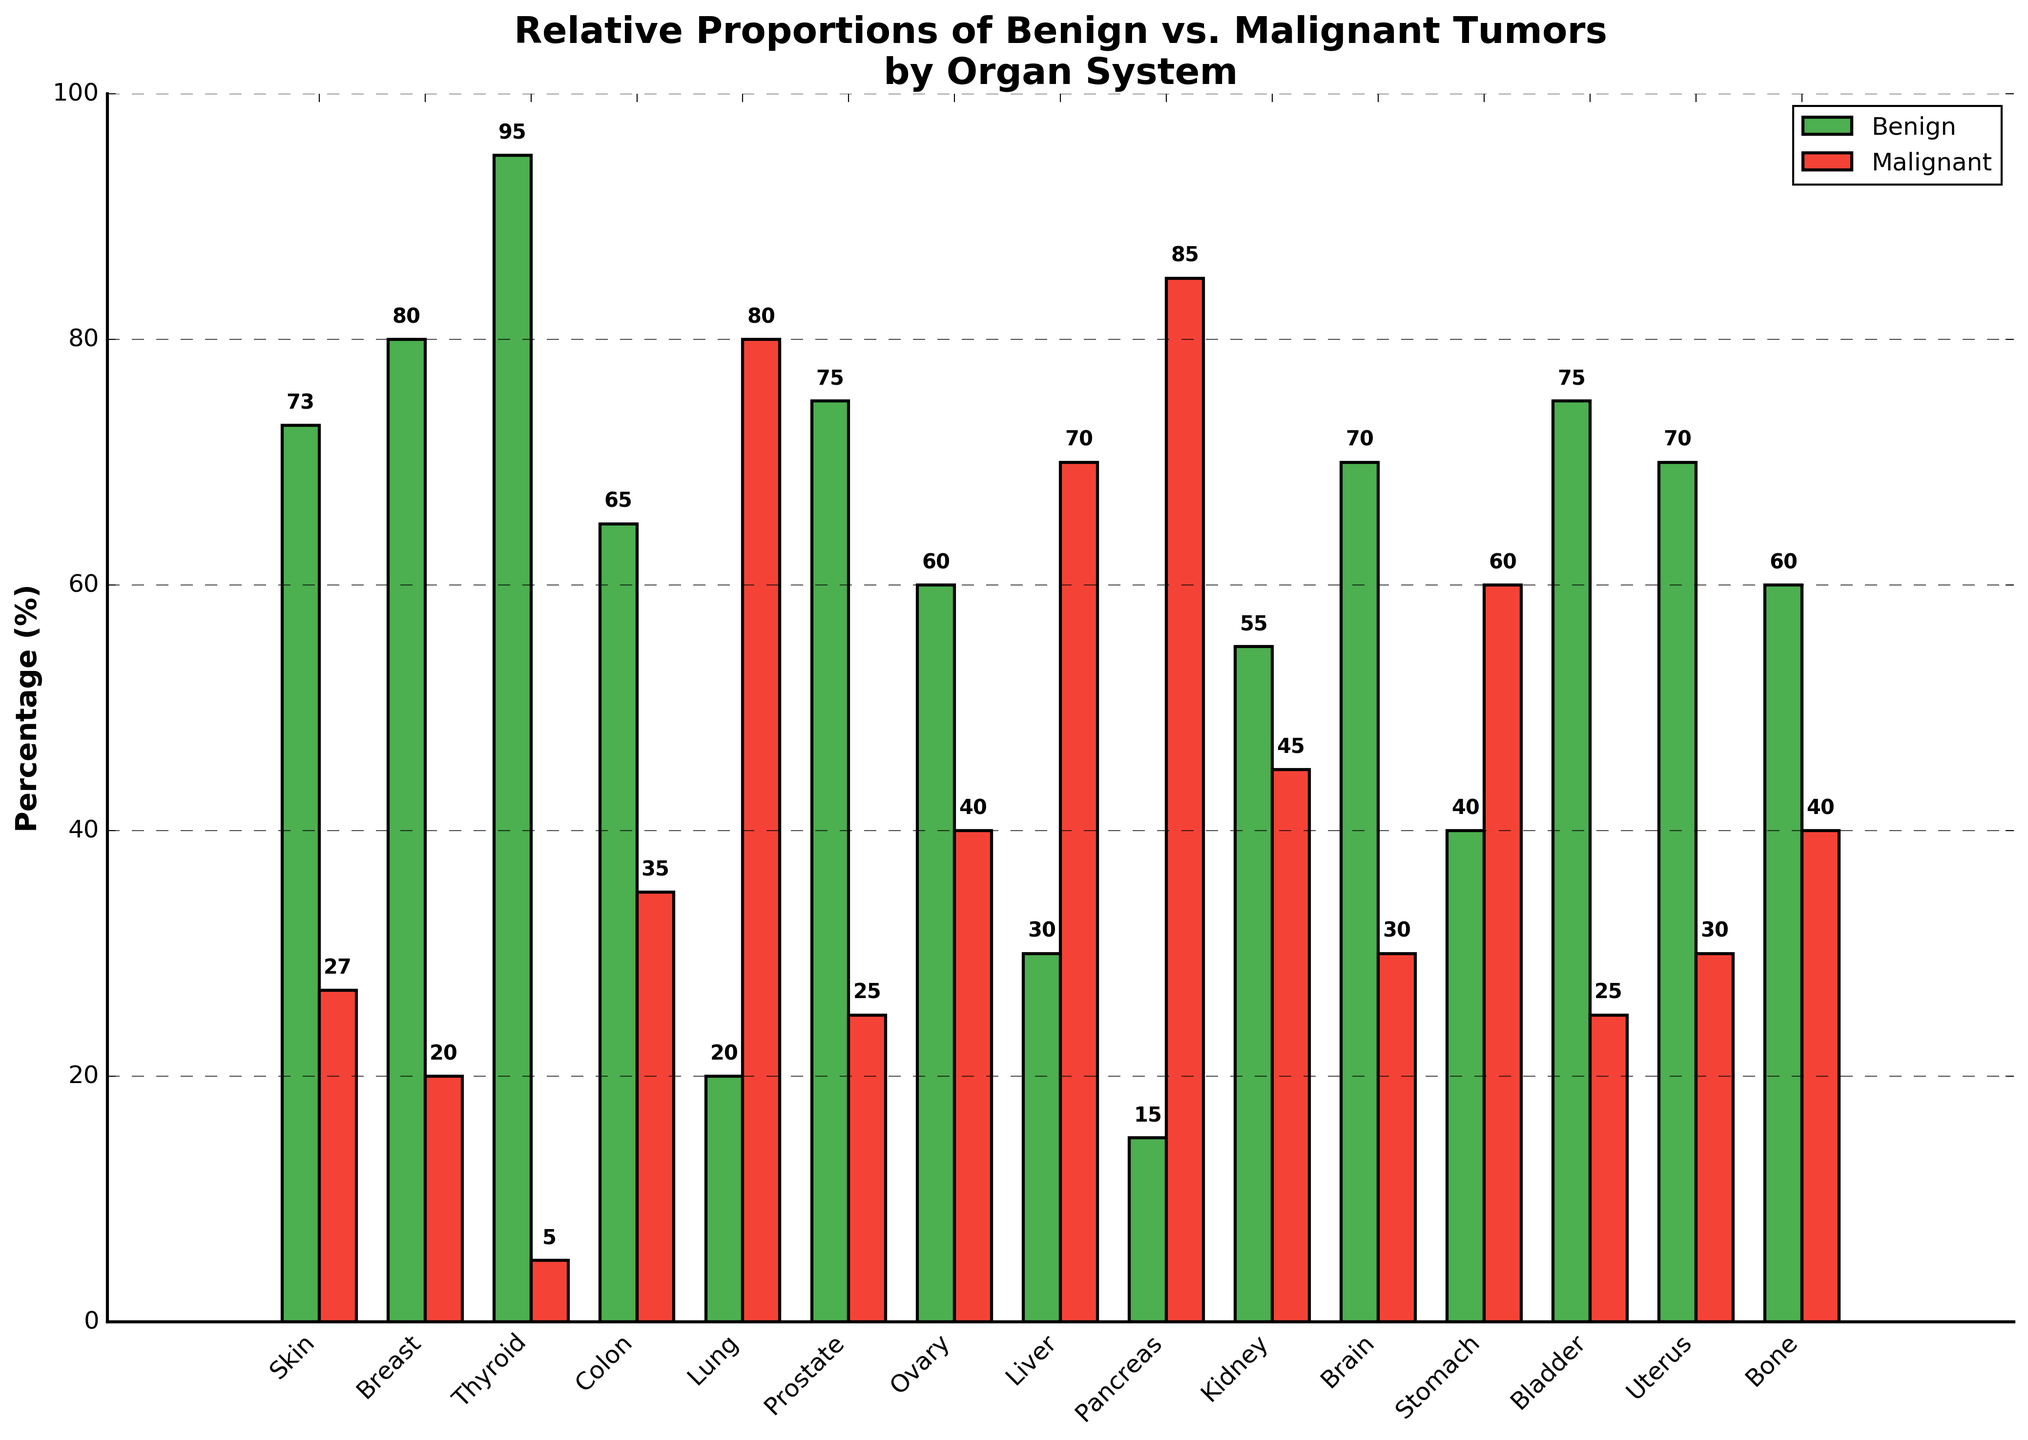What organ system shows the highest percentage of benign tumors? Check which bar labeled "Benign" has the highest value. The Thyroid system has a "Benign" percentage of 95%, which is the highest.
Answer: Thyroid Which organ system has a higher proportion of malignant tumors, Lung or Stomach? Compare the "Malignant" percentages for Lung and Stomach. Lung has 80% and Stomach has 60%, so Lung is higher.
Answer: Lung What is the difference in the percentage of benign tumors between the Skin and Liver? Subtract the "Benign" percentage of Liver from Skin. Skin has 73% benign, and Liver has 30% benign. 73% - 30% = 43%.
Answer: 43% Comparing Brain and Kidney, which organ system has a closer balance between benign and malignant tumors? Look at the "Benign" and "Malignant" percentages for Brain (70%/30%) and Kidney (55%/45%). Kidney's percentages are closer to each other.
Answer: Kidney What is the total percentage of benign tumors across Breast and Prostate? Add the "Benign" percentages for Breast and Prostate. Breast has 80% and Prostate has 75%. 80% + 75% = 155%.
Answer: 155% Which organ system has the smallest difference between the percentages of benign and malignant tumors? Calculate the difference for each system and identify the smallest. Uterus has 70% benign and 30% malignant, a difference of 40%, which is the smallest difference.
Answer: Uterus How many organ systems have a higher proportion of benign tumors compared to malignant tumors? Count the number of systems where the "Benign" percentage is higher than the "Malignant" percentage. There are 10 such systems: Skin, Breast, Thyroid, Colon, Prostate, Ovary, Kidney, Brain, Bladder, and Uterus.
Answer: 10 Which organ system has the highest proportion of malignant tumors? Check which bar labeled "Malignant" has the highest value. The Pancreas system has a "Malignant" percentage of 85%, which is the highest.
Answer: Pancreas What is the average percentage of benign tumors across all organ systems? Sum all "Benign" percentages and divide by the number of systems, which is 15. (73 + 80 + 95 + 65 + 20 + 75 + 60 + 30 + 15 + 55 + 70 + 40 + 75 + 70 + 60) = 883; 883/15 = 58.87%.
Answer: 58.87% Which organ system has the equal proportions of benign and malignant tumors closest to 50% each? Identify the system where benign and malignant percentages are closest to 50% each. Kidney has benign (55%) and malignant (45%) percentages, which are closest to 50%.
Answer: Kidney 